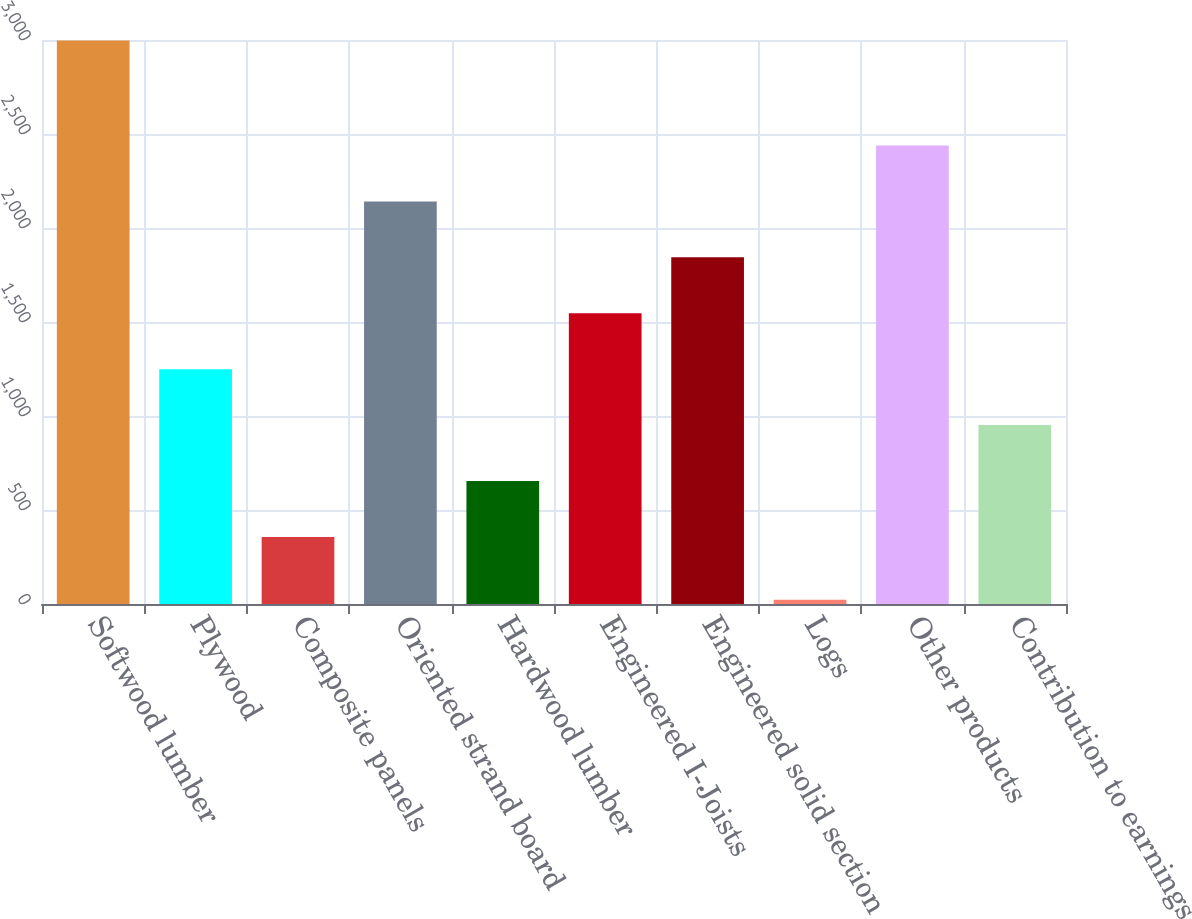<chart> <loc_0><loc_0><loc_500><loc_500><bar_chart><fcel>Softwood lumber<fcel>Plywood<fcel>Composite panels<fcel>Oriented strand board<fcel>Hardwood lumber<fcel>Engineered I-Joists<fcel>Engineered solid section<fcel>Logs<fcel>Other products<fcel>Contribution to earnings<nl><fcel>2997<fcel>1249.2<fcel>357<fcel>2141.4<fcel>654.4<fcel>1546.6<fcel>1844<fcel>23<fcel>2438.8<fcel>951.8<nl></chart> 